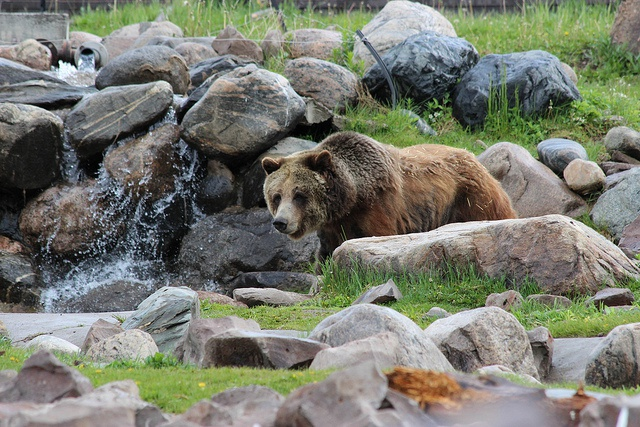Describe the objects in this image and their specific colors. I can see a bear in gray, black, and maroon tones in this image. 